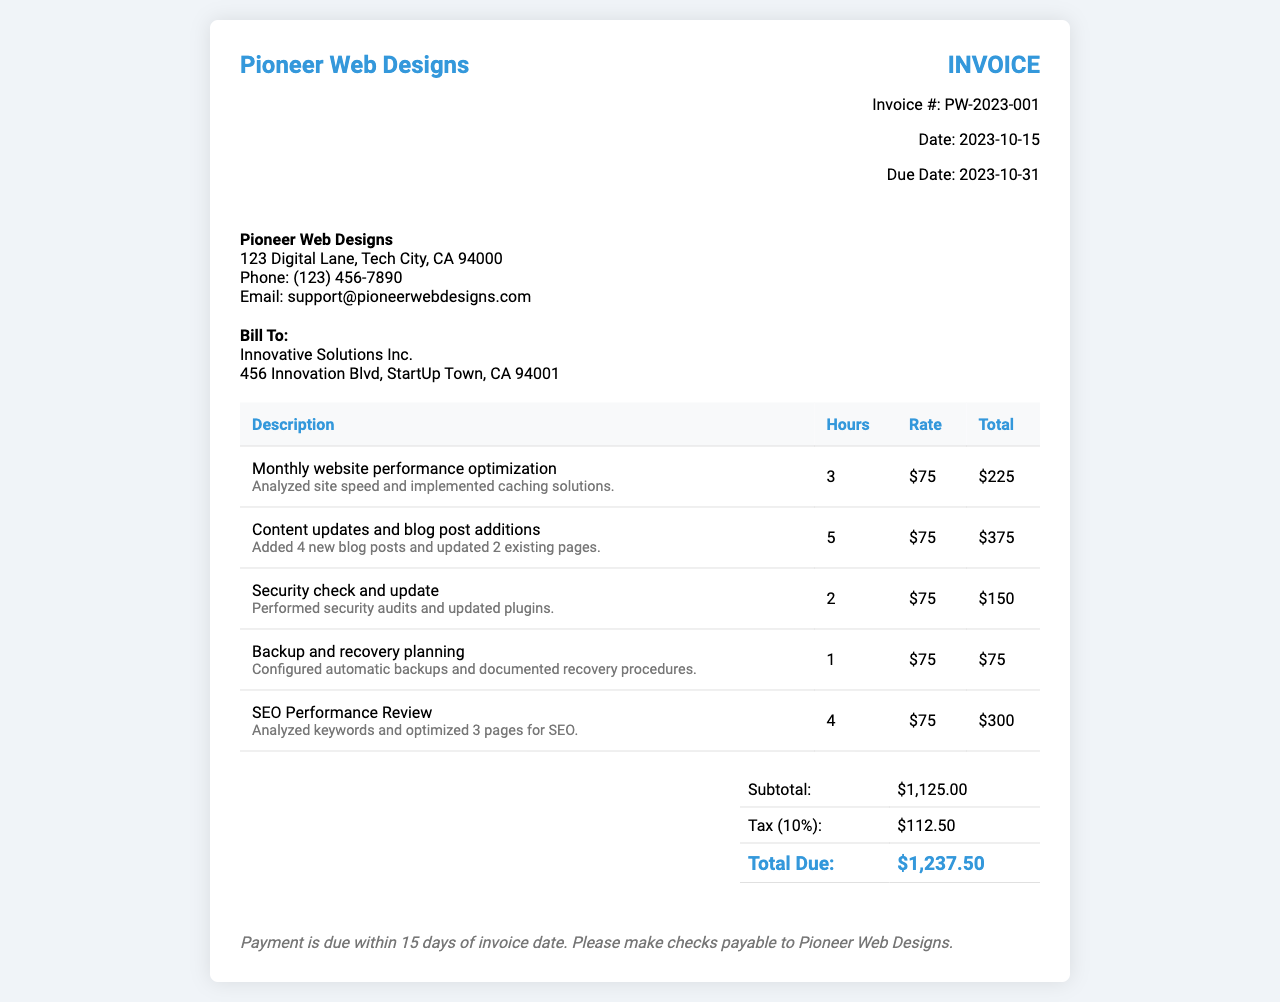What is the invoice number? The invoice number is listed at the top right corner of the invoice under "Invoice #".
Answer: PW-2023-001 Who is the billed company? The billed company name is found in the section labeled "Bill To:".
Answer: Innovative Solutions Inc What is the due date for the invoice? The due date is provided in the invoice details section under "Due Date:".
Answer: 2023-10-31 How many hours were spent on security checks? The hours spent for each task are detailed in the corresponding table row for security checks.
Answer: 2 What is the total amount due? The total amount due is at the bottom of the summary table, indicated as "Total Due:".
Answer: $1,237.50 What service involved adding blog posts? The specific service that included adding blog posts is listed in the task description in the table.
Answer: Content updates and blog post additions What percentage tax was applied to the invoice? The applied tax percentage is mentioned in the summary table under "Tax".
Answer: 10% Which task had the least number of hours billed? The task with the least number of hours is indicated in the hours column of the table.
Answer: Backup and recovery planning What was the rate per hour for services? The rate per hour is uniformly given under the "Rate" column in the table.
Answer: $75 